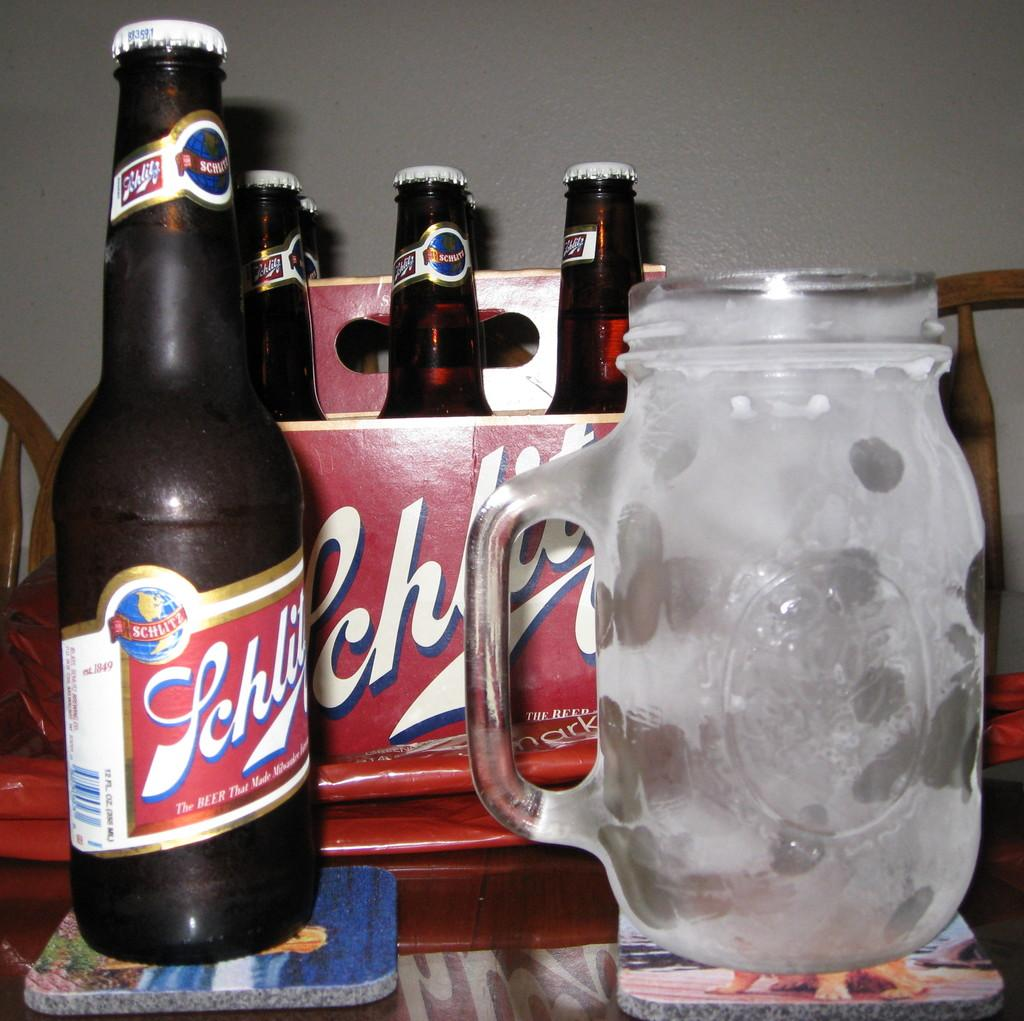<image>
Render a clear and concise summary of the photo. A bottle of Schlitz beer is next to a chilled mug. 